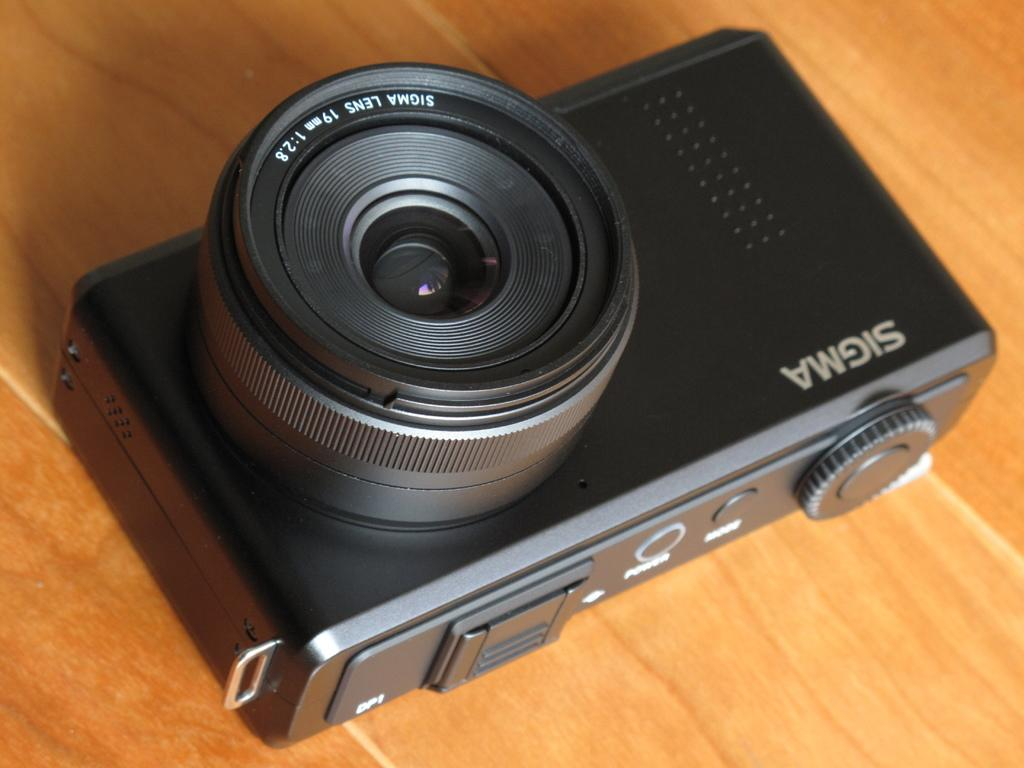What is the main subject of the image? The main subject of the image is a camera. Where is the camera located in the image? The camera is in the center of the image. What is the camera resting on in the image? The camera is on a table. What type of taste does the camera have in the image? Cameras do not have tastes, as they are inanimate objects. 